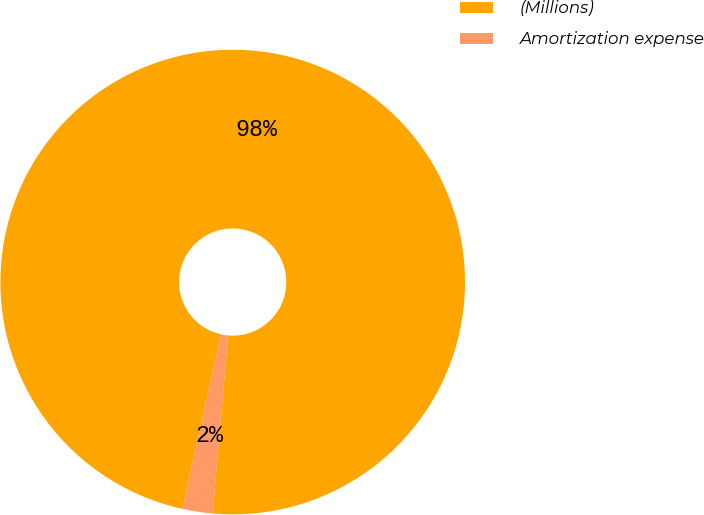Convert chart to OTSL. <chart><loc_0><loc_0><loc_500><loc_500><pie_chart><fcel>(Millions)<fcel>Amortization expense<nl><fcel>97.9%<fcel>2.1%<nl></chart> 